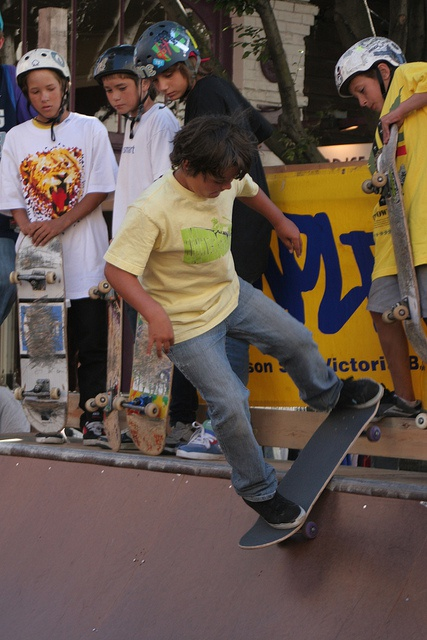Describe the objects in this image and their specific colors. I can see people in black, gray, and tan tones, people in black, lavender, and darkgray tones, people in black, olive, maroon, and gray tones, skateboard in black, gray, and darkgray tones, and people in black and darkgray tones in this image. 